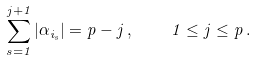Convert formula to latex. <formula><loc_0><loc_0><loc_500><loc_500>\sum _ { s = 1 } ^ { j + 1 } | \alpha _ { i _ { s } } | = p - j \, , \quad 1 \leq j \leq p \, .</formula> 